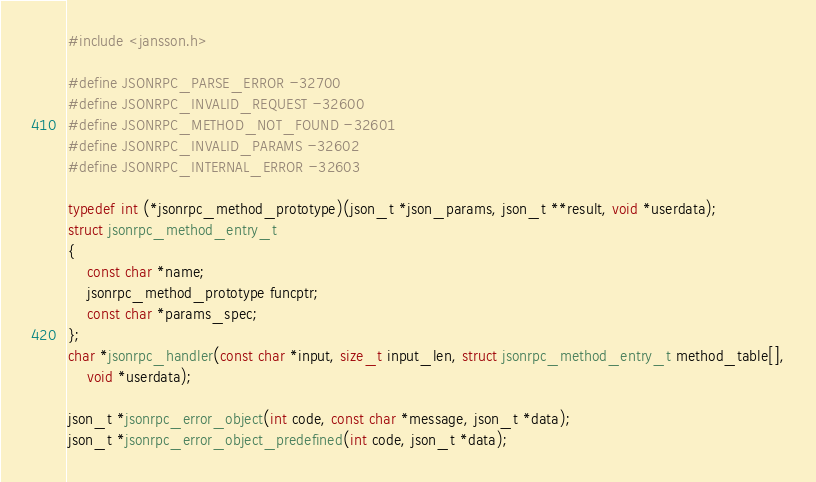Convert code to text. <code><loc_0><loc_0><loc_500><loc_500><_C_>#include <jansson.h>

#define JSONRPC_PARSE_ERROR -32700
#define JSONRPC_INVALID_REQUEST -32600
#define JSONRPC_METHOD_NOT_FOUND -32601
#define JSONRPC_INVALID_PARAMS -32602
#define JSONRPC_INTERNAL_ERROR -32603

typedef int (*jsonrpc_method_prototype)(json_t *json_params, json_t **result, void *userdata);
struct jsonrpc_method_entry_t
{
	const char *name;
	jsonrpc_method_prototype funcptr;
	const char *params_spec;
};
char *jsonrpc_handler(const char *input, size_t input_len, struct jsonrpc_method_entry_t method_table[],
	void *userdata);

json_t *jsonrpc_error_object(int code, const char *message, json_t *data);
json_t *jsonrpc_error_object_predefined(int code, json_t *data);

</code> 